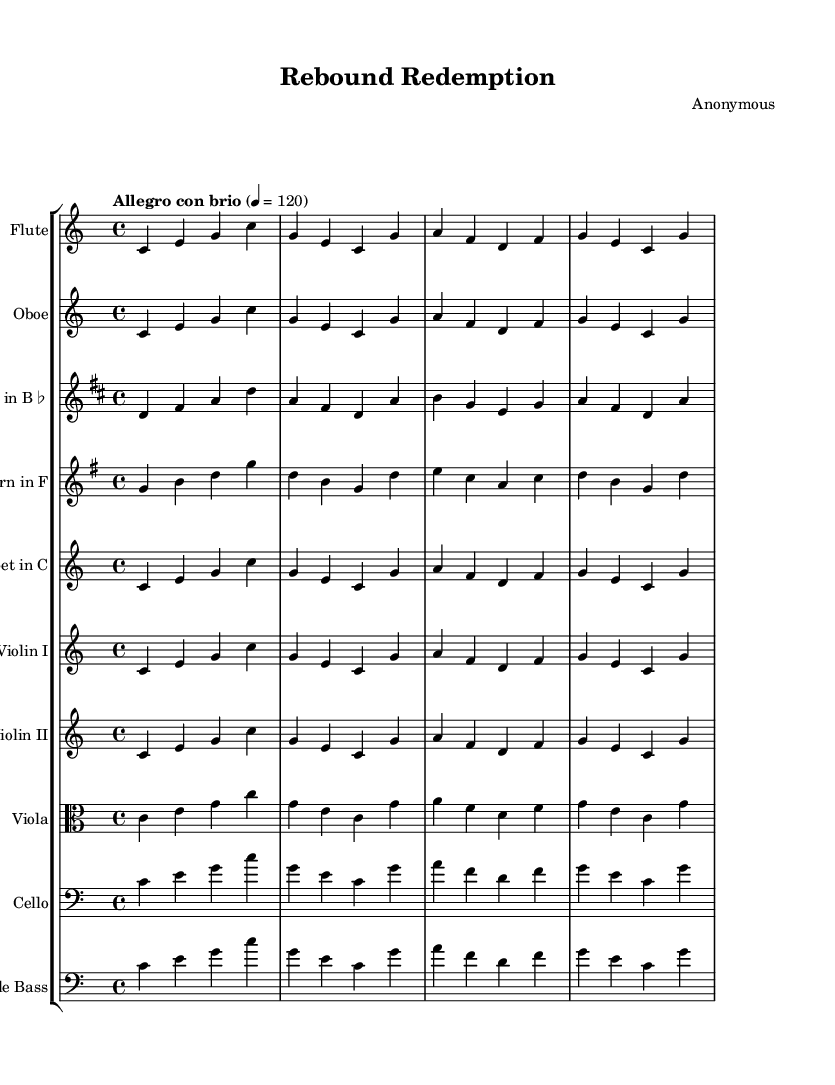What is the key signature of this music? The key signature indicated at the beginning of the score is C major, which has no sharps or flats.
Answer: C major What is the time signature of this music? The time signature is shown at the beginning of the score; it reads "4/4," indicating there are four beats in a measure.
Answer: 4/4 What is the tempo marking in this piece? The tempo marking written above the score states "Allegro con brio," which signals a fast and lively pace.
Answer: Allegro con brio How many instruments are in the score? By counting the individual staves listed in the score, there are nine instruments total, each having its own staff.
Answer: Nine What is the primary melodic structure of the symphony? The main melody outlined in the score is a sequence of notes, with the pattern starting from C and rising through several notes, indicating the melodic theme.
Answer: C E G What are the two lowest instruments included in this symphonic work? The score includes both Cello and Double Bass as the two lowest instruments, which are indicated in bass clef.
Answer: Cello and Double Bass What are the woodwind instruments present in this piece? The score lists Flute, Oboe, and Clarinet in B flat as the woodwind instruments used in this symphony.
Answer: Flute, Oboe, Clarinet in B flat 